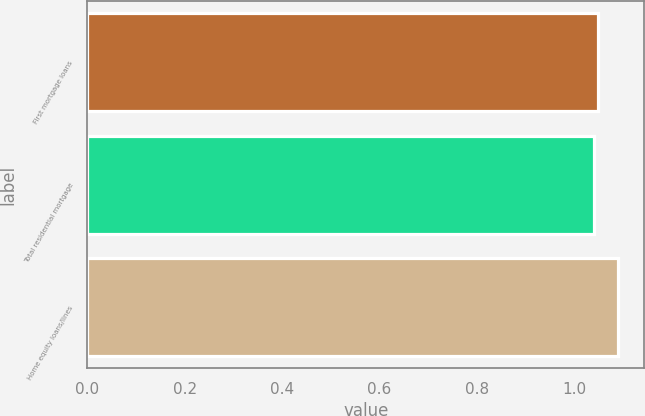<chart> <loc_0><loc_0><loc_500><loc_500><bar_chart><fcel>First mortgage loans<fcel>Total residential mortgage<fcel>Home equity loans/lines<nl><fcel>1.05<fcel>1.04<fcel>1.09<nl></chart> 